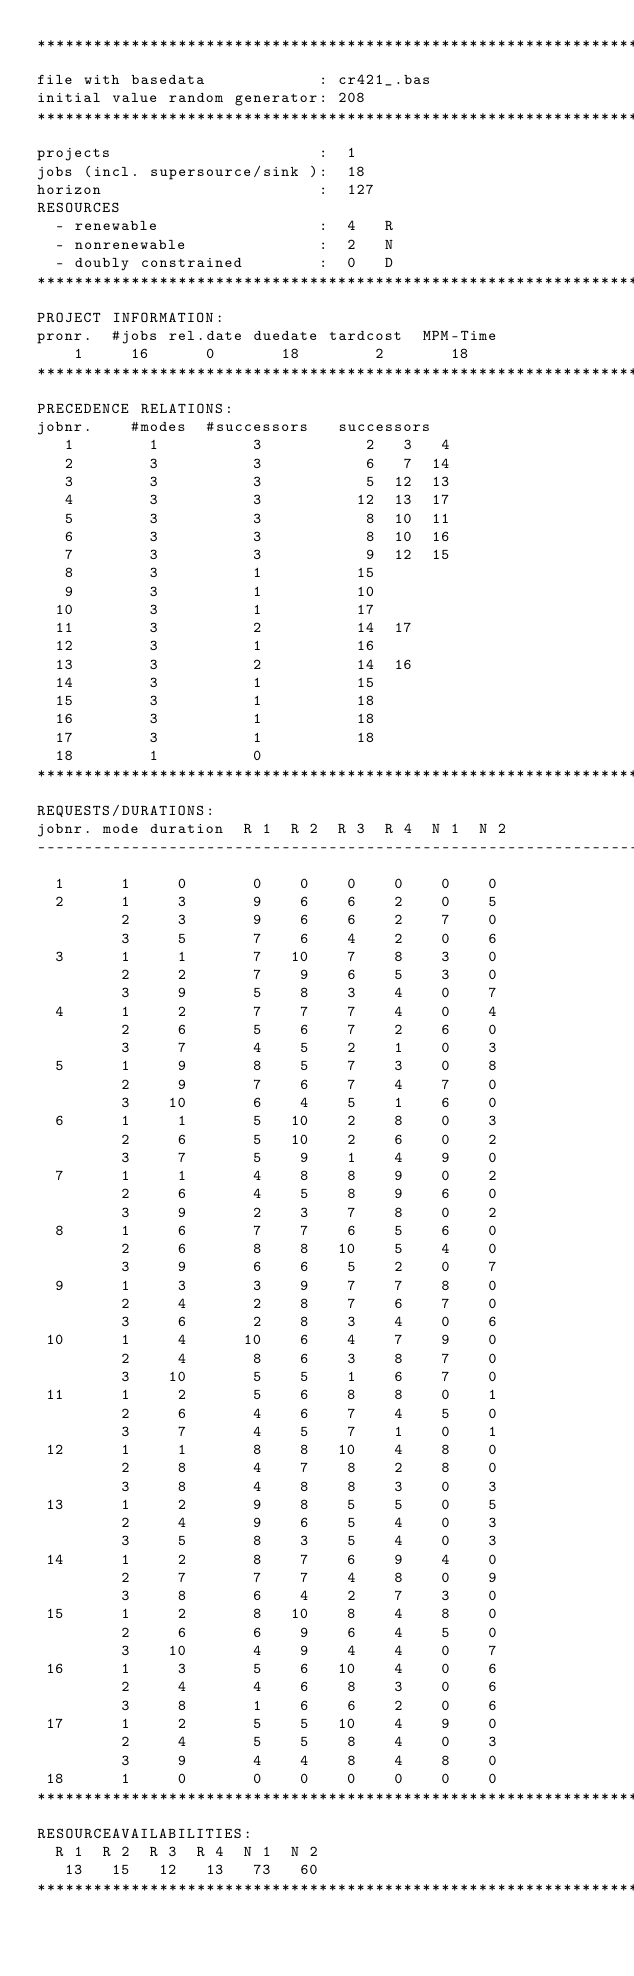<code> <loc_0><loc_0><loc_500><loc_500><_ObjectiveC_>************************************************************************
file with basedata            : cr421_.bas
initial value random generator: 208
************************************************************************
projects                      :  1
jobs (incl. supersource/sink ):  18
horizon                       :  127
RESOURCES
  - renewable                 :  4   R
  - nonrenewable              :  2   N
  - doubly constrained        :  0   D
************************************************************************
PROJECT INFORMATION:
pronr.  #jobs rel.date duedate tardcost  MPM-Time
    1     16      0       18        2       18
************************************************************************
PRECEDENCE RELATIONS:
jobnr.    #modes  #successors   successors
   1        1          3           2   3   4
   2        3          3           6   7  14
   3        3          3           5  12  13
   4        3          3          12  13  17
   5        3          3           8  10  11
   6        3          3           8  10  16
   7        3          3           9  12  15
   8        3          1          15
   9        3          1          10
  10        3          1          17
  11        3          2          14  17
  12        3          1          16
  13        3          2          14  16
  14        3          1          15
  15        3          1          18
  16        3          1          18
  17        3          1          18
  18        1          0        
************************************************************************
REQUESTS/DURATIONS:
jobnr. mode duration  R 1  R 2  R 3  R 4  N 1  N 2
------------------------------------------------------------------------
  1      1     0       0    0    0    0    0    0
  2      1     3       9    6    6    2    0    5
         2     3       9    6    6    2    7    0
         3     5       7    6    4    2    0    6
  3      1     1       7   10    7    8    3    0
         2     2       7    9    6    5    3    0
         3     9       5    8    3    4    0    7
  4      1     2       7    7    7    4    0    4
         2     6       5    6    7    2    6    0
         3     7       4    5    2    1    0    3
  5      1     9       8    5    7    3    0    8
         2     9       7    6    7    4    7    0
         3    10       6    4    5    1    6    0
  6      1     1       5   10    2    8    0    3
         2     6       5   10    2    6    0    2
         3     7       5    9    1    4    9    0
  7      1     1       4    8    8    9    0    2
         2     6       4    5    8    9    6    0
         3     9       2    3    7    8    0    2
  8      1     6       7    7    6    5    6    0
         2     6       8    8   10    5    4    0
         3     9       6    6    5    2    0    7
  9      1     3       3    9    7    7    8    0
         2     4       2    8    7    6    7    0
         3     6       2    8    3    4    0    6
 10      1     4      10    6    4    7    9    0
         2     4       8    6    3    8    7    0
         3    10       5    5    1    6    7    0
 11      1     2       5    6    8    8    0    1
         2     6       4    6    7    4    5    0
         3     7       4    5    7    1    0    1
 12      1     1       8    8   10    4    8    0
         2     8       4    7    8    2    8    0
         3     8       4    8    8    3    0    3
 13      1     2       9    8    5    5    0    5
         2     4       9    6    5    4    0    3
         3     5       8    3    5    4    0    3
 14      1     2       8    7    6    9    4    0
         2     7       7    7    4    8    0    9
         3     8       6    4    2    7    3    0
 15      1     2       8   10    8    4    8    0
         2     6       6    9    6    4    5    0
         3    10       4    9    4    4    0    7
 16      1     3       5    6   10    4    0    6
         2     4       4    6    8    3    0    6
         3     8       1    6    6    2    0    6
 17      1     2       5    5   10    4    9    0
         2     4       5    5    8    4    0    3
         3     9       4    4    8    4    8    0
 18      1     0       0    0    0    0    0    0
************************************************************************
RESOURCEAVAILABILITIES:
  R 1  R 2  R 3  R 4  N 1  N 2
   13   15   12   13   73   60
************************************************************************
</code> 